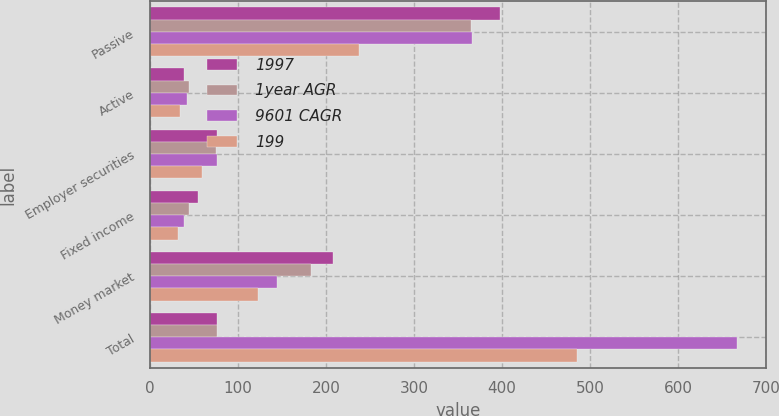<chart> <loc_0><loc_0><loc_500><loc_500><stacked_bar_chart><ecel><fcel>Passive<fcel>Active<fcel>Employer securities<fcel>Fixed income<fcel>Money market<fcel>Total<nl><fcel>1997<fcel>398<fcel>39<fcel>76<fcel>54<fcel>208<fcel>76<nl><fcel>1year AGR<fcel>365<fcel>44<fcel>75<fcel>44<fcel>183<fcel>76<nl><fcel>9601 CAGR<fcel>366<fcel>42<fcel>76<fcel>39<fcel>144<fcel>667<nl><fcel>199<fcel>237<fcel>34<fcel>59<fcel>32<fcel>123<fcel>485<nl></chart> 